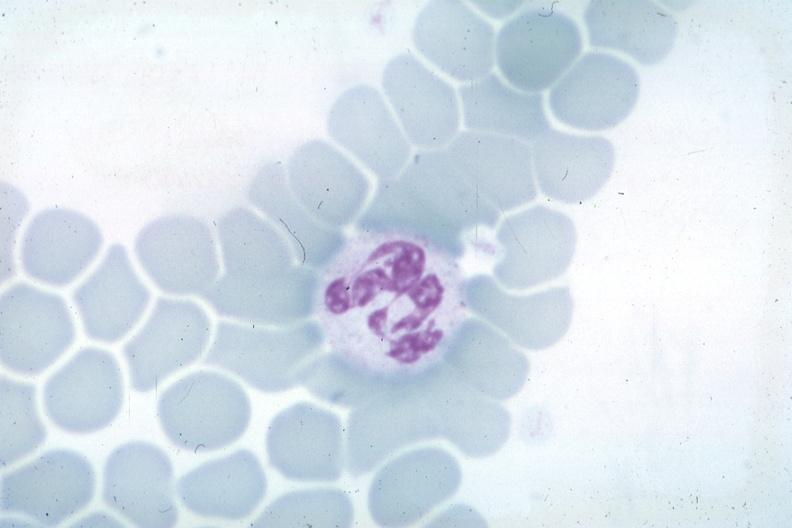what is obvious source unknown?
Answer the question using a single word or phrase. Wrights not the best photograph for color but nuclear change 